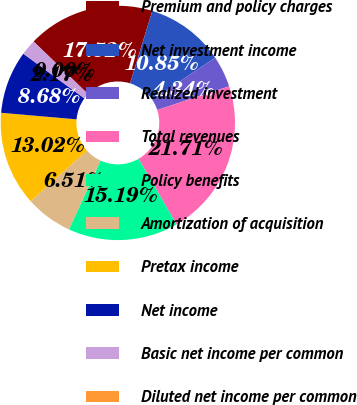Convert chart to OTSL. <chart><loc_0><loc_0><loc_500><loc_500><pie_chart><fcel>Premium and policy charges<fcel>Net investment income<fcel>Realized investment<fcel>Total revenues<fcel>Policy benefits<fcel>Amortization of acquisition<fcel>Pretax income<fcel>Net income<fcel>Basic net income per common<fcel>Diluted net income per common<nl><fcel>17.52%<fcel>10.85%<fcel>4.34%<fcel>21.71%<fcel>15.19%<fcel>6.51%<fcel>13.02%<fcel>8.68%<fcel>2.17%<fcel>0.0%<nl></chart> 